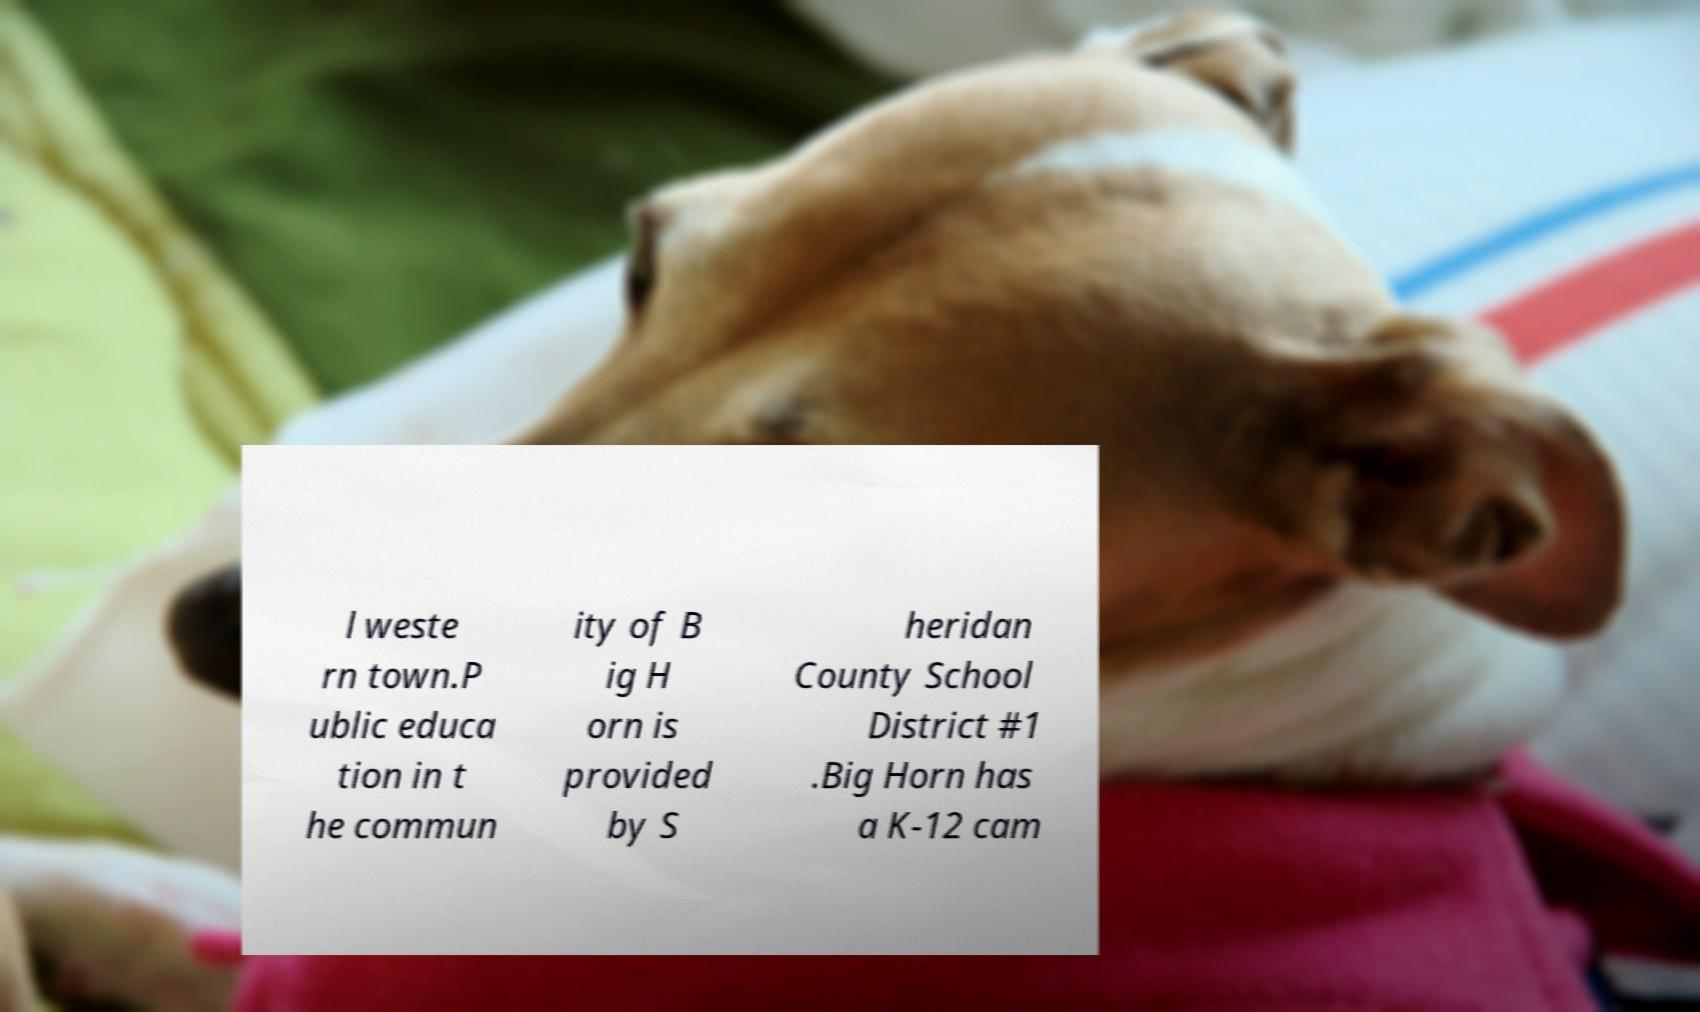Please read and relay the text visible in this image. What does it say? l weste rn town.P ublic educa tion in t he commun ity of B ig H orn is provided by S heridan County School District #1 .Big Horn has a K-12 cam 